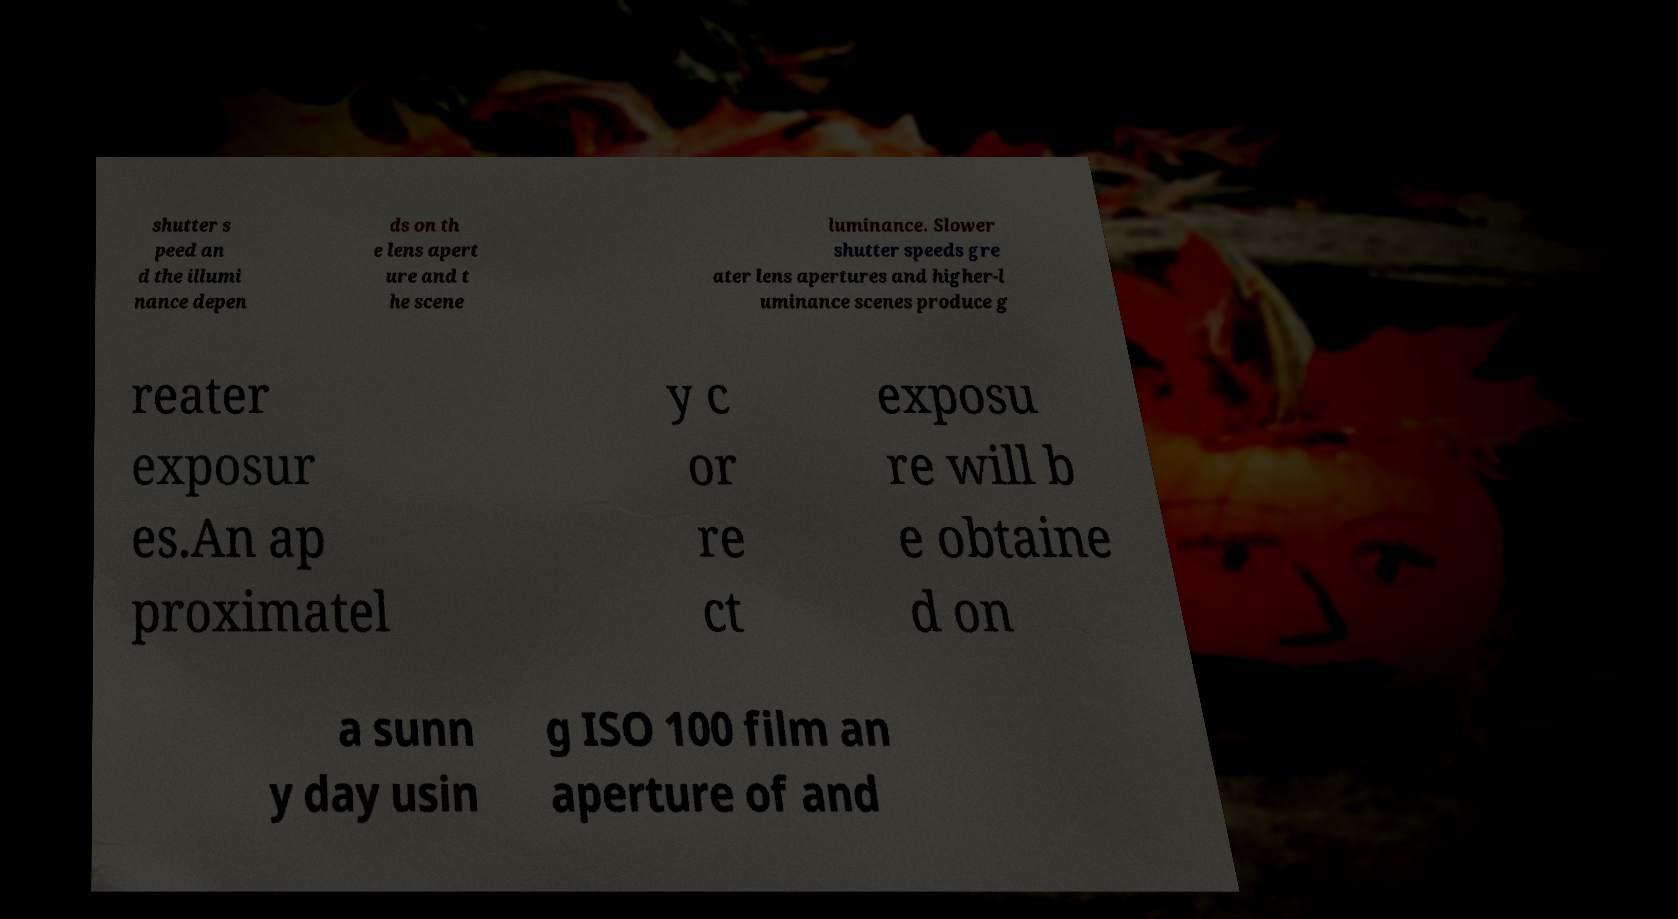I need the written content from this picture converted into text. Can you do that? shutter s peed an d the illumi nance depen ds on th e lens apert ure and t he scene luminance. Slower shutter speeds gre ater lens apertures and higher-l uminance scenes produce g reater exposur es.An ap proximatel y c or re ct exposu re will b e obtaine d on a sunn y day usin g ISO 100 film an aperture of and 